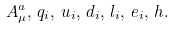Convert formula to latex. <formula><loc_0><loc_0><loc_500><loc_500>A _ { \mu } ^ { a } , \, q _ { i } , \, u _ { i } , \, d _ { i } , \, l _ { i } , \, e _ { i } , \, h .</formula> 